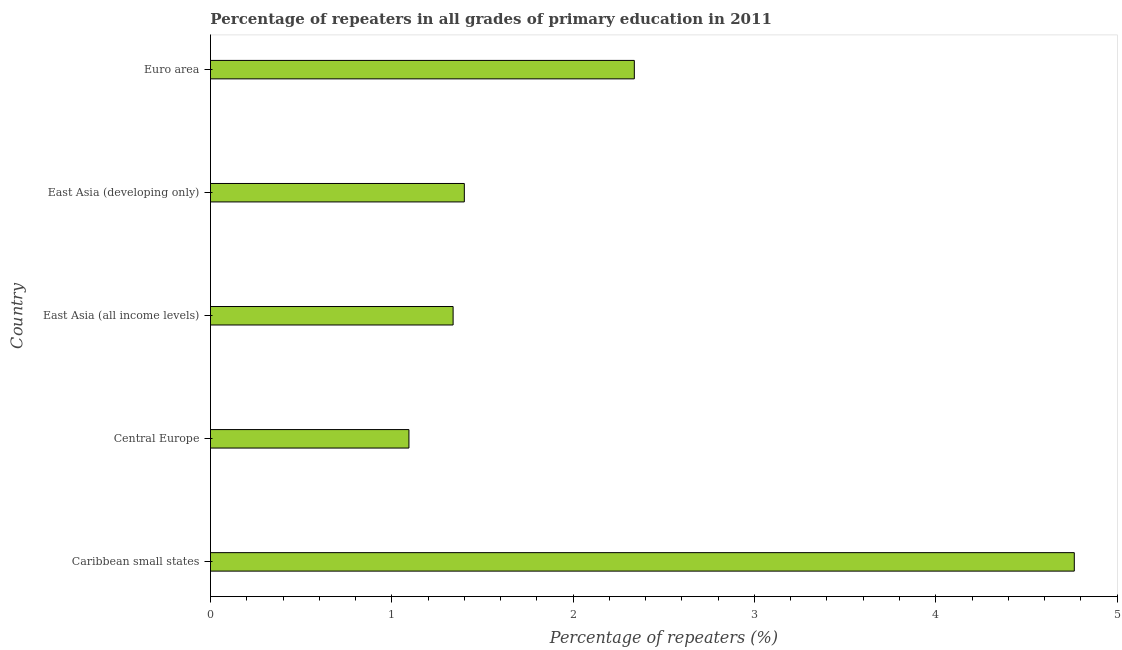Does the graph contain grids?
Offer a very short reply. No. What is the title of the graph?
Provide a succinct answer. Percentage of repeaters in all grades of primary education in 2011. What is the label or title of the X-axis?
Provide a short and direct response. Percentage of repeaters (%). What is the percentage of repeaters in primary education in Euro area?
Your response must be concise. 2.34. Across all countries, what is the maximum percentage of repeaters in primary education?
Make the answer very short. 4.76. Across all countries, what is the minimum percentage of repeaters in primary education?
Provide a succinct answer. 1.09. In which country was the percentage of repeaters in primary education maximum?
Provide a succinct answer. Caribbean small states. In which country was the percentage of repeaters in primary education minimum?
Your answer should be very brief. Central Europe. What is the sum of the percentage of repeaters in primary education?
Provide a short and direct response. 10.93. What is the difference between the percentage of repeaters in primary education in Central Europe and East Asia (all income levels)?
Keep it short and to the point. -0.24. What is the average percentage of repeaters in primary education per country?
Offer a very short reply. 2.19. What is the median percentage of repeaters in primary education?
Your answer should be compact. 1.4. In how many countries, is the percentage of repeaters in primary education greater than 1 %?
Your response must be concise. 5. What is the ratio of the percentage of repeaters in primary education in Central Europe to that in Euro area?
Your response must be concise. 0.47. Is the percentage of repeaters in primary education in Caribbean small states less than that in East Asia (all income levels)?
Your answer should be compact. No. What is the difference between the highest and the second highest percentage of repeaters in primary education?
Offer a very short reply. 2.43. Is the sum of the percentage of repeaters in primary education in Caribbean small states and East Asia (all income levels) greater than the maximum percentage of repeaters in primary education across all countries?
Offer a terse response. Yes. What is the difference between the highest and the lowest percentage of repeaters in primary education?
Your answer should be very brief. 3.67. In how many countries, is the percentage of repeaters in primary education greater than the average percentage of repeaters in primary education taken over all countries?
Ensure brevity in your answer.  2. What is the difference between two consecutive major ticks on the X-axis?
Make the answer very short. 1. Are the values on the major ticks of X-axis written in scientific E-notation?
Provide a succinct answer. No. What is the Percentage of repeaters (%) of Caribbean small states?
Offer a terse response. 4.76. What is the Percentage of repeaters (%) in Central Europe?
Your answer should be very brief. 1.09. What is the Percentage of repeaters (%) in East Asia (all income levels)?
Ensure brevity in your answer.  1.34. What is the Percentage of repeaters (%) of East Asia (developing only)?
Ensure brevity in your answer.  1.4. What is the Percentage of repeaters (%) in Euro area?
Keep it short and to the point. 2.34. What is the difference between the Percentage of repeaters (%) in Caribbean small states and Central Europe?
Your response must be concise. 3.67. What is the difference between the Percentage of repeaters (%) in Caribbean small states and East Asia (all income levels)?
Make the answer very short. 3.43. What is the difference between the Percentage of repeaters (%) in Caribbean small states and East Asia (developing only)?
Keep it short and to the point. 3.36. What is the difference between the Percentage of repeaters (%) in Caribbean small states and Euro area?
Provide a succinct answer. 2.43. What is the difference between the Percentage of repeaters (%) in Central Europe and East Asia (all income levels)?
Your response must be concise. -0.24. What is the difference between the Percentage of repeaters (%) in Central Europe and East Asia (developing only)?
Make the answer very short. -0.31. What is the difference between the Percentage of repeaters (%) in Central Europe and Euro area?
Offer a very short reply. -1.24. What is the difference between the Percentage of repeaters (%) in East Asia (all income levels) and East Asia (developing only)?
Make the answer very short. -0.06. What is the difference between the Percentage of repeaters (%) in East Asia (all income levels) and Euro area?
Ensure brevity in your answer.  -1. What is the difference between the Percentage of repeaters (%) in East Asia (developing only) and Euro area?
Your answer should be very brief. -0.94. What is the ratio of the Percentage of repeaters (%) in Caribbean small states to that in Central Europe?
Provide a succinct answer. 4.35. What is the ratio of the Percentage of repeaters (%) in Caribbean small states to that in East Asia (all income levels)?
Offer a very short reply. 3.56. What is the ratio of the Percentage of repeaters (%) in Caribbean small states to that in East Asia (developing only)?
Keep it short and to the point. 3.4. What is the ratio of the Percentage of repeaters (%) in Caribbean small states to that in Euro area?
Offer a terse response. 2.04. What is the ratio of the Percentage of repeaters (%) in Central Europe to that in East Asia (all income levels)?
Make the answer very short. 0.82. What is the ratio of the Percentage of repeaters (%) in Central Europe to that in East Asia (developing only)?
Provide a short and direct response. 0.78. What is the ratio of the Percentage of repeaters (%) in Central Europe to that in Euro area?
Give a very brief answer. 0.47. What is the ratio of the Percentage of repeaters (%) in East Asia (all income levels) to that in East Asia (developing only)?
Make the answer very short. 0.96. What is the ratio of the Percentage of repeaters (%) in East Asia (all income levels) to that in Euro area?
Offer a terse response. 0.57. What is the ratio of the Percentage of repeaters (%) in East Asia (developing only) to that in Euro area?
Offer a terse response. 0.6. 